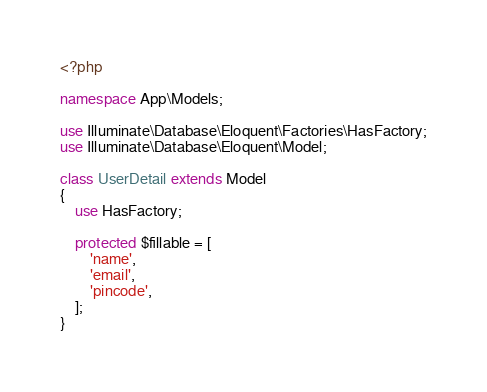Convert code to text. <code><loc_0><loc_0><loc_500><loc_500><_PHP_><?php

namespace App\Models;

use Illuminate\Database\Eloquent\Factories\HasFactory;
use Illuminate\Database\Eloquent\Model;

class UserDetail extends Model
{
    use HasFactory;

    protected $fillable = [
        'name',
        'email',
        'pincode',
    ];
}
</code> 